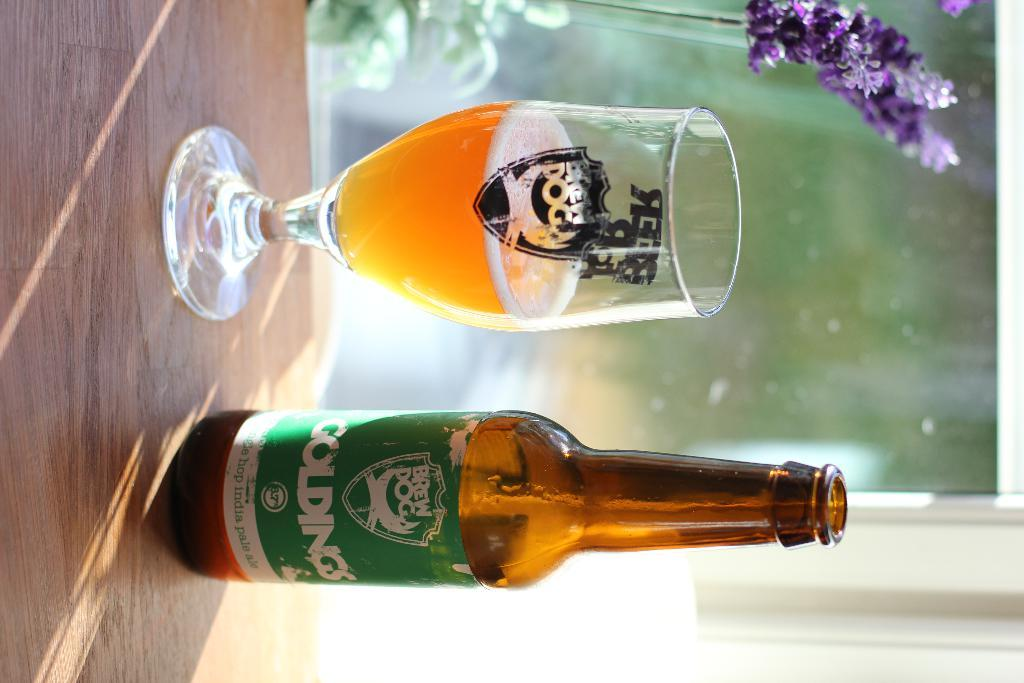Provide a one-sentence caption for the provided image. A Goldings beer sits next to a cup with beer. 